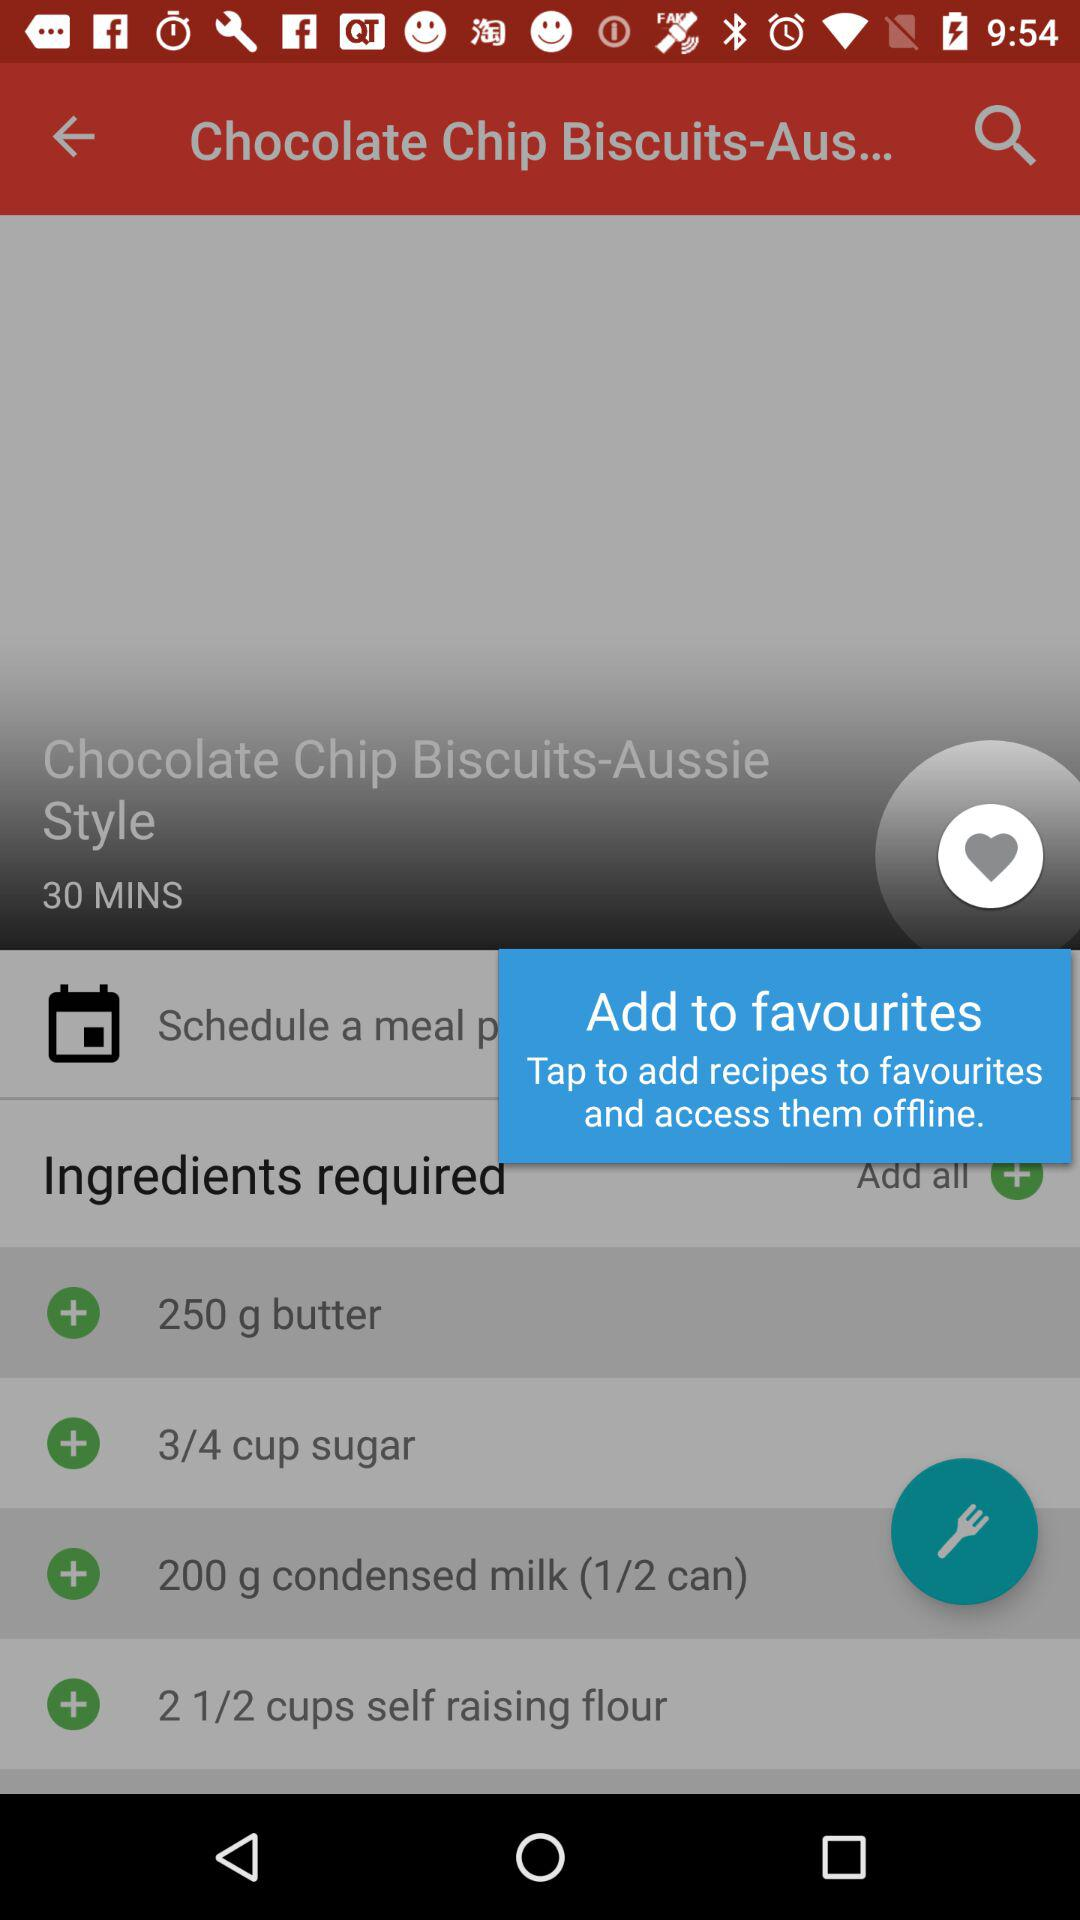How many servings does the recipe make?
When the provided information is insufficient, respond with <no answer>. <no answer> 